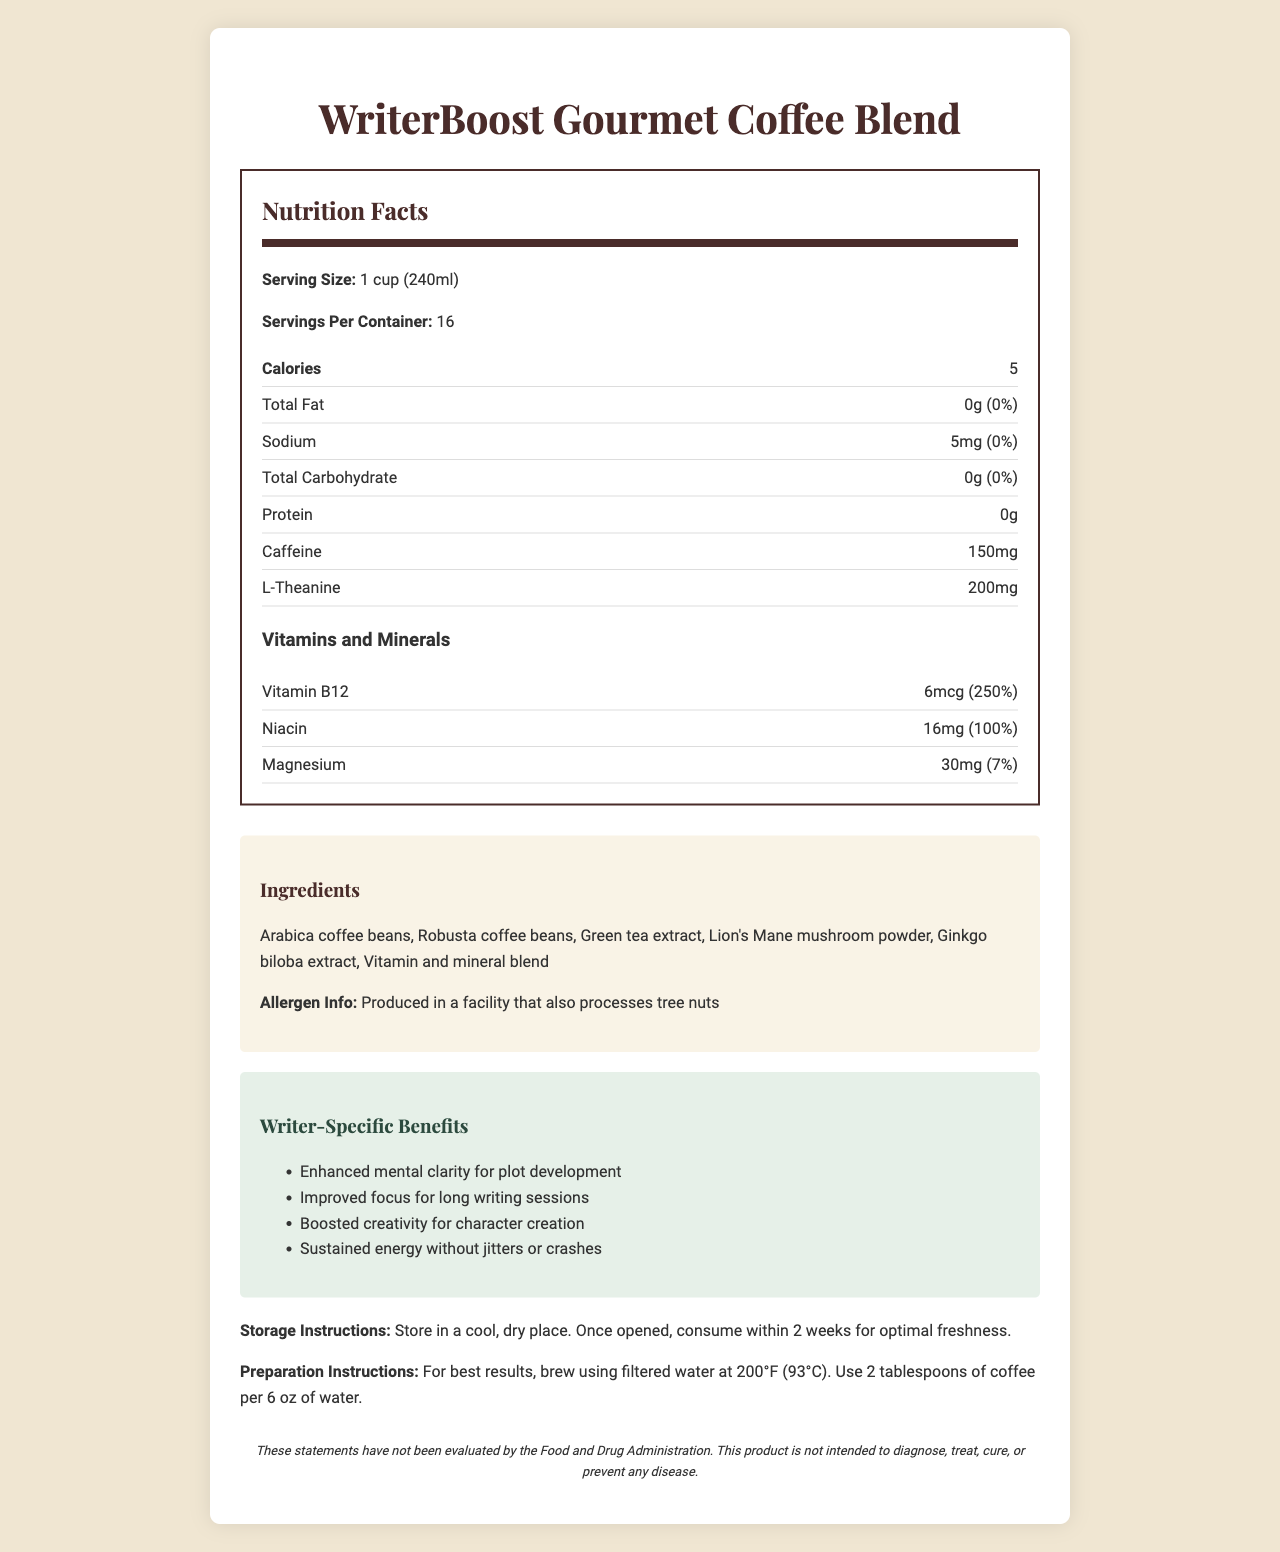what is the serving size? The serving size is clearly stated as "1 cup (240ml)" at the beginning of the Nutrition Facts section.
Answer: 1 cup (240ml) how many servings are there per container? The number of servings per container is explicitly listed as "16" in the document.
Answer: 16 how many calories are in one serving? The calories per serving are mentioned as "5" under the Nutrition Facts.
Answer: 5 what is the amount of caffeine in each serving? The document mentions that each serving contains "150mg" of caffeine.
Answer: 150mg are there any fats in this coffee blend? The Nutrition Facts show "Total Fat" as "0g" with a daily value of "0%," indicating there are no fats.
Answer: No what is the daily value of Vitamin B12? A. 50% B. 100% C. 250% D. 300% The document lists the daily value of Vitamin B12 as "250%."
Answer: C. 250% which ingredient is not included in the WriterBoost Gourmet Coffee Blend? A. Arabica coffee beans B. Green tea extract C. Sugar D. Ginkgo biloba extract The list of ingredients includes Arabica coffee beans, Green tea extract, and Ginkgo biloba extract but does not mention sugar.
Answer: C. Sugar is this product safe for people with tree nut allergies? The allergen information states that the product is produced in a facility that also processes tree nuts.
Answer: No what specific benefits does this coffee offer to writers? The writer-specific benefits section elaborates on the specific advantages the coffee provides to writers.
Answer: Enhanced mental clarity for plot development, Improved focus for long writing sessions, Boosted creativity for character creation, Sustained energy without jitters or crashes what are the main ingredients in this coffee blend? The main ingredients are listed in the ingredients section.
Answer: Arabica coffee beans, Robusta coffee beans, Green tea extract, Lion's Mane mushroom powder, Ginkgo biloba extract, Vitamin and mineral blend how should this coffee be stored? Storage instructions clearly mention to store it in a cool, dry place and consume within 2 weeks after opening.
Answer: Store in a cool, dry place. Once opened, consume within 2 weeks for optimal freshness. what is the main idea of this document? This detailed summary covers the purpose and content of the document, including its target audience and main features.
Answer: Summary: The document provides the Nutrition Facts, ingredient list, preparation instructions, and writer-specific benefits for the WriterBoost Gourmet Coffee Blend, a specially formulated coffee designed to enhance creativity and focus for writers. how much protein is in one serving? A. 0g B. 1g C. 2g D. 5g The document lists the protein content as "0g".
Answer: A. 0g does this product contain any dietary fibers? The Nutrition Facts do not list any dietary fibers.
Answer: No, it does not contain any dietary fibers. what is the daily value percentage of Niacin? The daily value percentage of Niacin is listed as "100%" in the vitamins and minerals section.
Answer: 100% is this product intended to treat any mental health conditions? The disclaimer clearly states that this product is not intended to diagnose, treat, cure, or prevent any disease.
Answer: No how should this coffee be prepared? The preparation instructions provide detailed steps for the best brewing results.
Answer: For best results, brew using filtered water at 200°F (93°C). Use 2 tablespoons of coffee per 6 oz of water. what is the daily value of sodium in this coffee blend? The sodium content has a daily value of "0%" as per the document.
Answer: 0% what are the potential allergens in this product? A. Milk B. Eggs C. Tree nuts D. Wheat The allergen information mentions that the product is produced in a facility that processes tree nuts.
Answer: C. Tree nuts what is the impact of caffeine in this coffee blend? Although not directly stated under caffeine, the writer-specific benefits section implies that the caffeine content helps with enhanced mental clarity and sustained energy.
Answer: Enhanced mental clarity and sustained energy how much Magnesium is in each serving? A. 20mg B. 25mg C. 30mg D. 35mg The vitamins and minerals section states that there are "30mg" of Magnesium per serving.
Answer: C. 30mg what are the effects of this coffee on writing productivity? The writer-specific benefits of the coffee blend all aim to improve various aspects of writing productivity.
Answer: Enhanced mental clarity, improved focus, boosted creativity, and sustained energy what type of coffee beans are used in this blend? The ingredients list mentions both Arabica and Robusta coffee beans.
Answer: Arabica coffee beans, Robusta coffee beans 